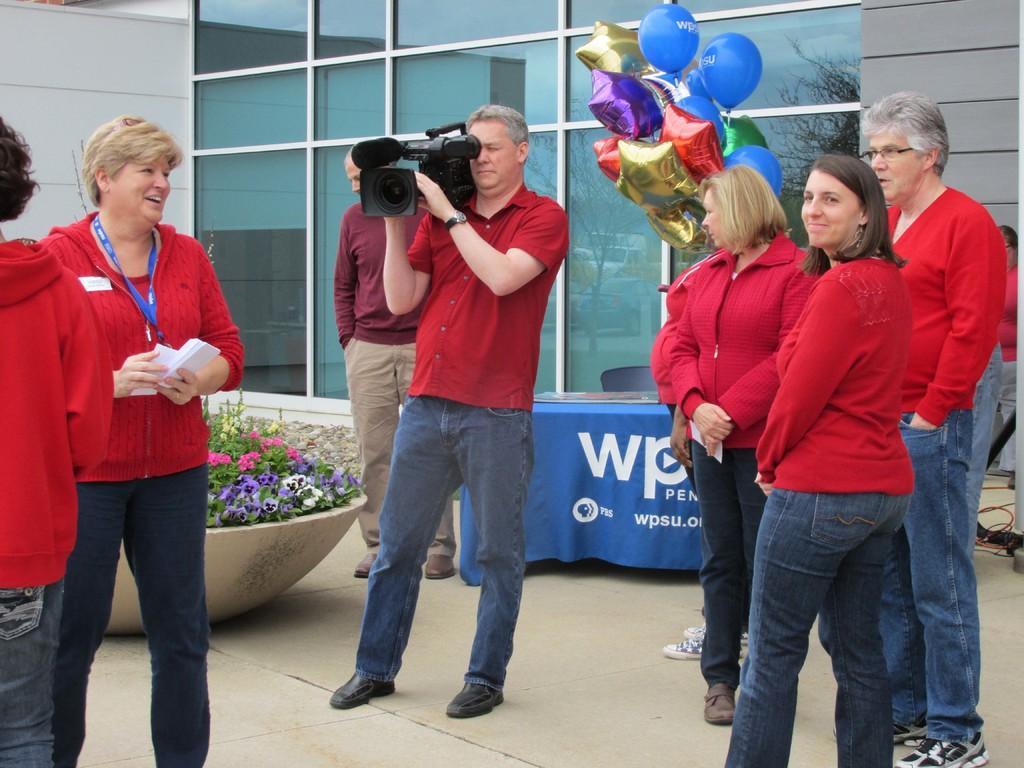Can you describe this image briefly? In this picture we can see some people are standing, a man in the middle is holding a camera, a woman on the left side is holding some papers, we can see a table, a chair and flower plants in the middle, there is a building in the background, on the right side there are some balloons. 